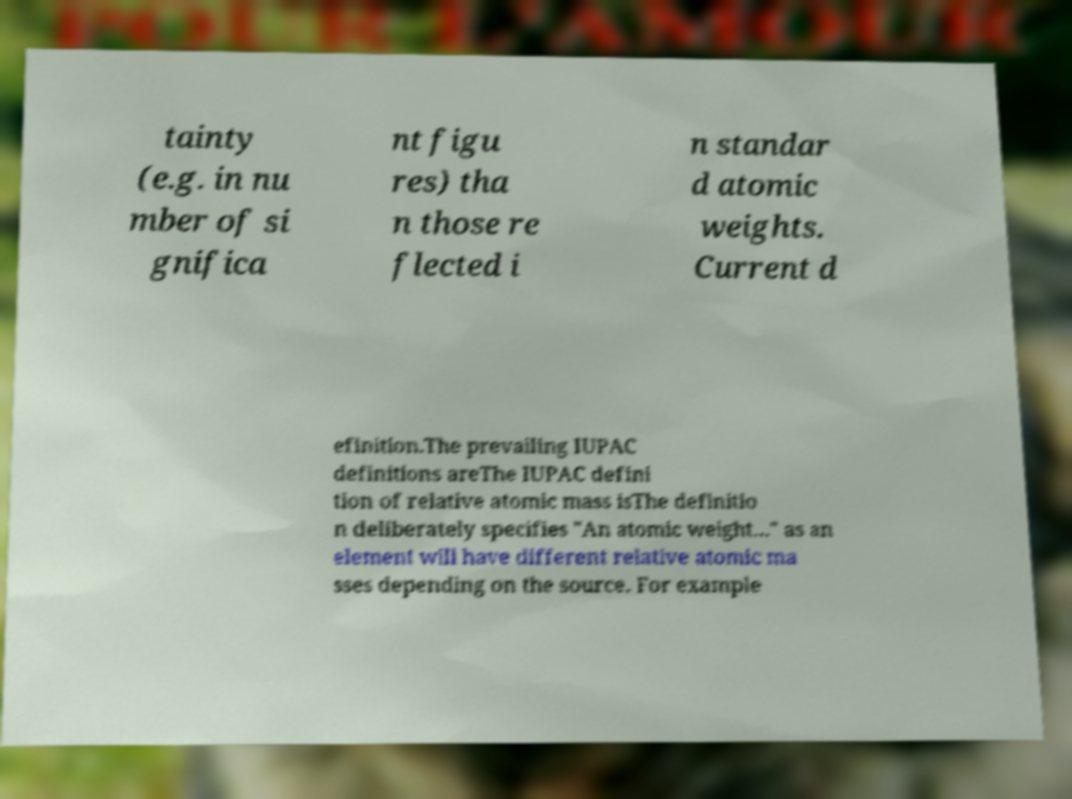What messages or text are displayed in this image? I need them in a readable, typed format. tainty (e.g. in nu mber of si gnifica nt figu res) tha n those re flected i n standar d atomic weights. Current d efinition.The prevailing IUPAC definitions areThe IUPAC defini tion of relative atomic mass isThe definitio n deliberately specifies "An atomic weight…" as an element will have different relative atomic ma sses depending on the source. For example 